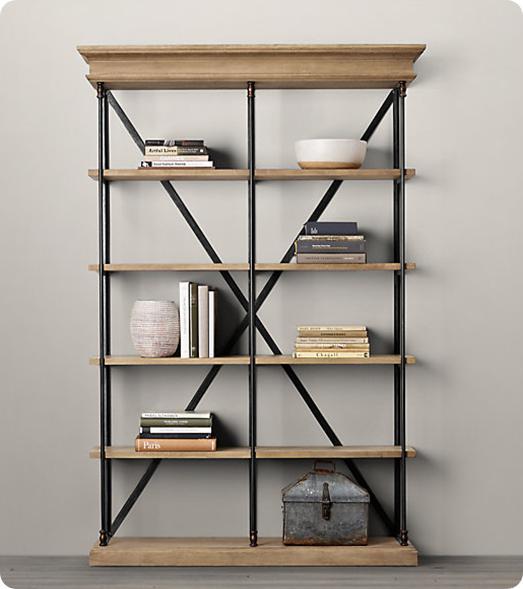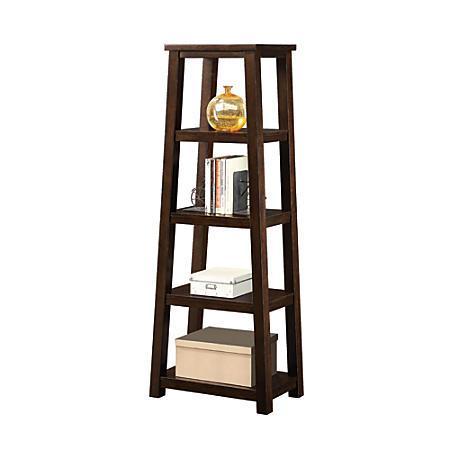The first image is the image on the left, the second image is the image on the right. Analyze the images presented: Is the assertion "One of the shelving units is up against a wall." valid? Answer yes or no. Yes. The first image is the image on the left, the second image is the image on the right. Examine the images to the left and right. Is the description "at least one bookshelf is empty" accurate? Answer yes or no. No. 